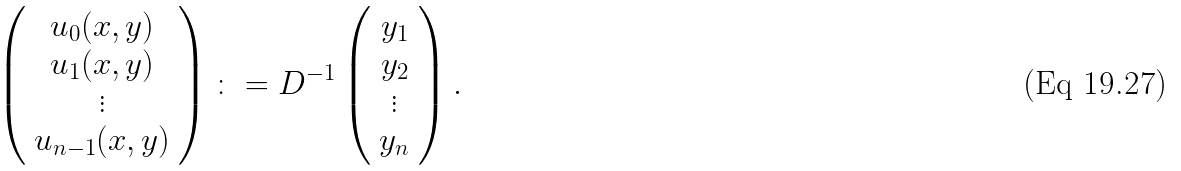Convert formula to latex. <formula><loc_0><loc_0><loc_500><loc_500>\left ( \begin{array} { c } u _ { 0 } ( x , y ) \\ u _ { 1 } ( x , y ) \\ \vdots \\ u _ { n - 1 } ( x , y ) \end{array} \right ) \colon = D ^ { - 1 } \left ( \begin{array} { c } y _ { 1 } \\ y _ { 2 } \\ \vdots \\ y _ { n } \end{array} \right ) .</formula> 